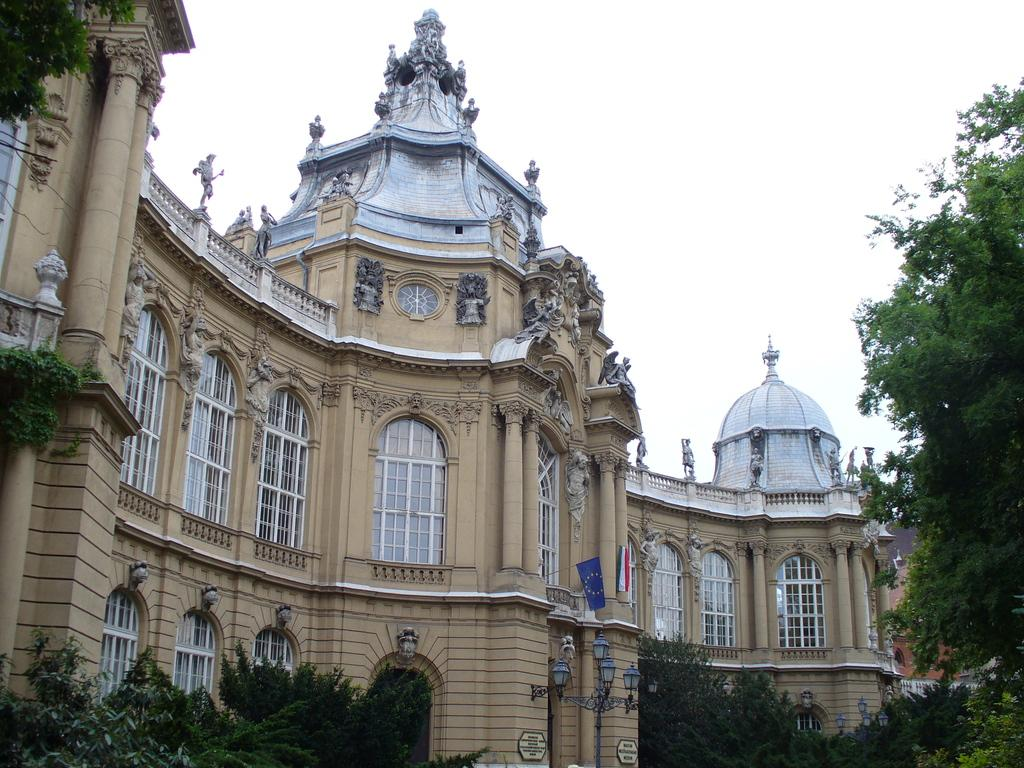What type of structure is present in the image? There is a building in the image. Are there any decorations or features on the building? Yes, the building has flags on it. What can be seen in the background of the image? There is sky visible in the background of the image. What type of natural elements are present in the image? There are trees in the image. What type of crime is being committed in the image? There is no indication of any crime being committed in the image. How many stamps are visible on the building in the image? There are no stamps visible on the building in the image. 